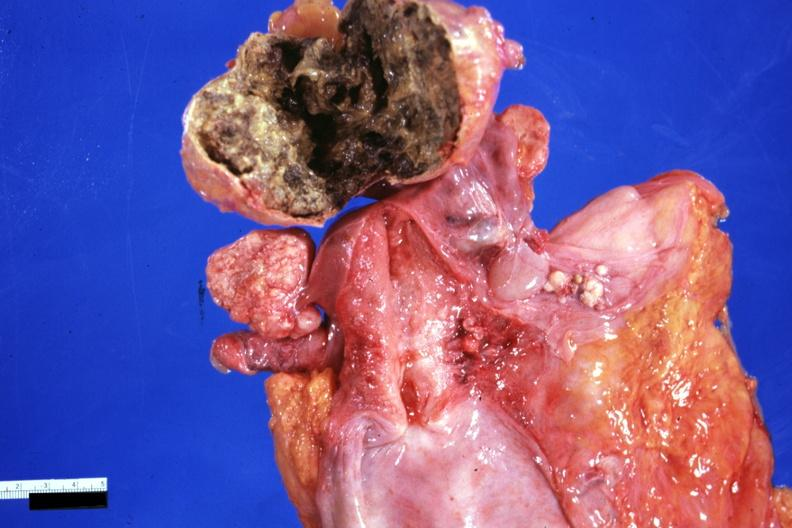s benign cystic teratoma present?
Answer the question using a single word or phrase. Yes 